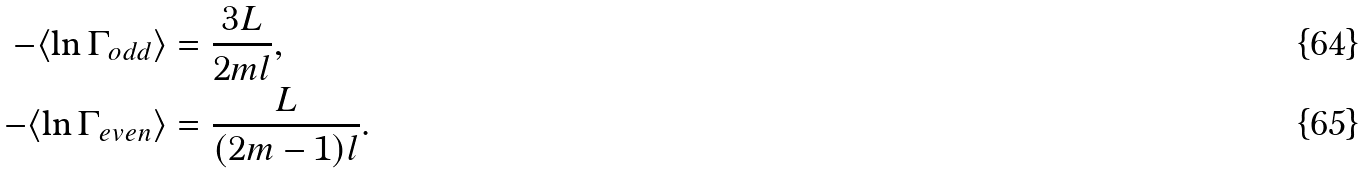<formula> <loc_0><loc_0><loc_500><loc_500>- \langle \ln \Gamma _ { o d d } \rangle & = \frac { 3 L } { 2 m l } , \\ - \langle \ln \Gamma _ { e v e n } \rangle & = \frac { L } { ( 2 m - 1 ) l } .</formula> 